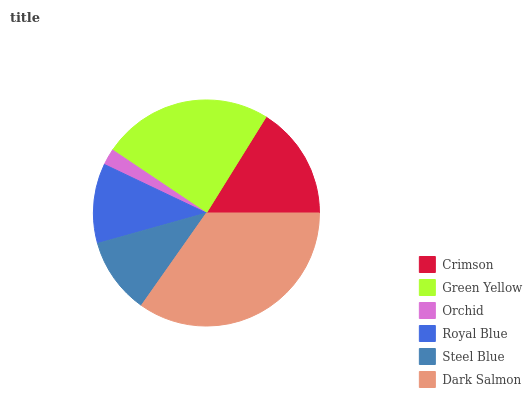Is Orchid the minimum?
Answer yes or no. Yes. Is Dark Salmon the maximum?
Answer yes or no. Yes. Is Green Yellow the minimum?
Answer yes or no. No. Is Green Yellow the maximum?
Answer yes or no. No. Is Green Yellow greater than Crimson?
Answer yes or no. Yes. Is Crimson less than Green Yellow?
Answer yes or no. Yes. Is Crimson greater than Green Yellow?
Answer yes or no. No. Is Green Yellow less than Crimson?
Answer yes or no. No. Is Crimson the high median?
Answer yes or no. Yes. Is Royal Blue the low median?
Answer yes or no. Yes. Is Steel Blue the high median?
Answer yes or no. No. Is Green Yellow the low median?
Answer yes or no. No. 